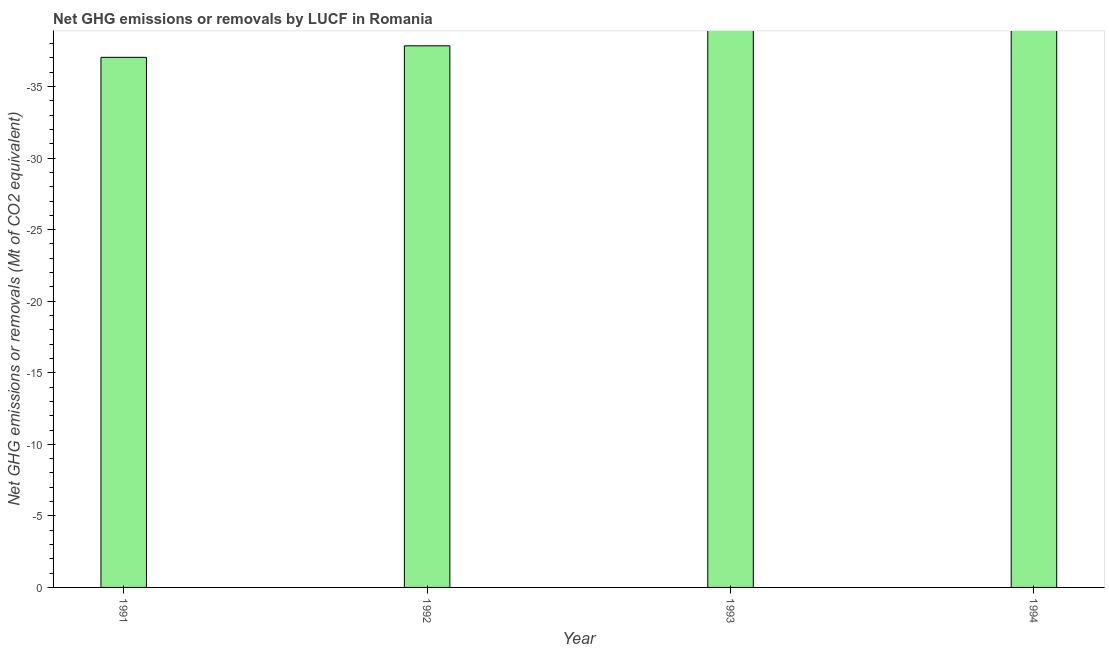What is the title of the graph?
Your response must be concise. Net GHG emissions or removals by LUCF in Romania. What is the label or title of the X-axis?
Your answer should be compact. Year. What is the label or title of the Y-axis?
Offer a very short reply. Net GHG emissions or removals (Mt of CO2 equivalent). What is the ghg net emissions or removals in 1993?
Your response must be concise. 0. What is the sum of the ghg net emissions or removals?
Give a very brief answer. 0. What is the average ghg net emissions or removals per year?
Your answer should be compact. 0. In how many years, is the ghg net emissions or removals greater than -27 Mt?
Give a very brief answer. 0. How many bars are there?
Keep it short and to the point. 0. How many years are there in the graph?
Ensure brevity in your answer.  4. What is the difference between two consecutive major ticks on the Y-axis?
Offer a very short reply. 5. What is the Net GHG emissions or removals (Mt of CO2 equivalent) in 1991?
Offer a terse response. 0. What is the Net GHG emissions or removals (Mt of CO2 equivalent) of 1992?
Offer a terse response. 0. 